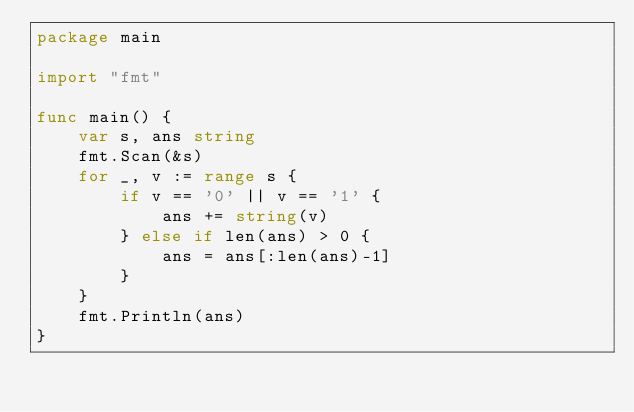Convert code to text. <code><loc_0><loc_0><loc_500><loc_500><_Go_>package main

import "fmt"

func main() {
	var s, ans string
	fmt.Scan(&s)
	for _, v := range s {
		if v == '0' || v == '1' {
			ans += string(v)
		} else if len(ans) > 0 {
			ans = ans[:len(ans)-1]
		}
	}
	fmt.Println(ans)
}
</code> 